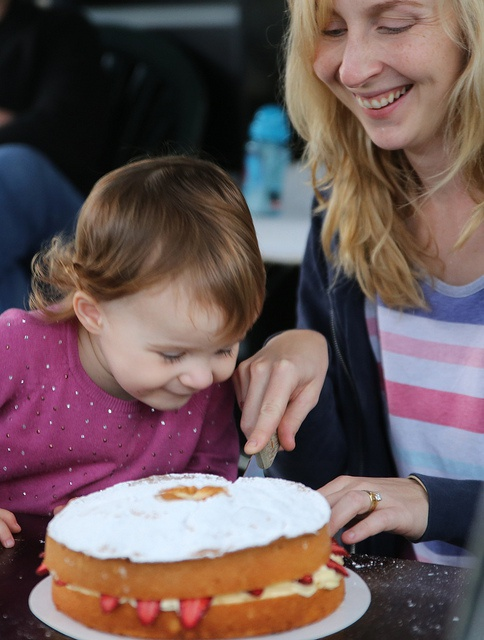Describe the objects in this image and their specific colors. I can see people in black, gray, and darkgray tones, people in black, purple, maroon, and brown tones, cake in black, lavender, red, salmon, and brown tones, chair in black and gray tones, and people in black, gray, and navy tones in this image. 